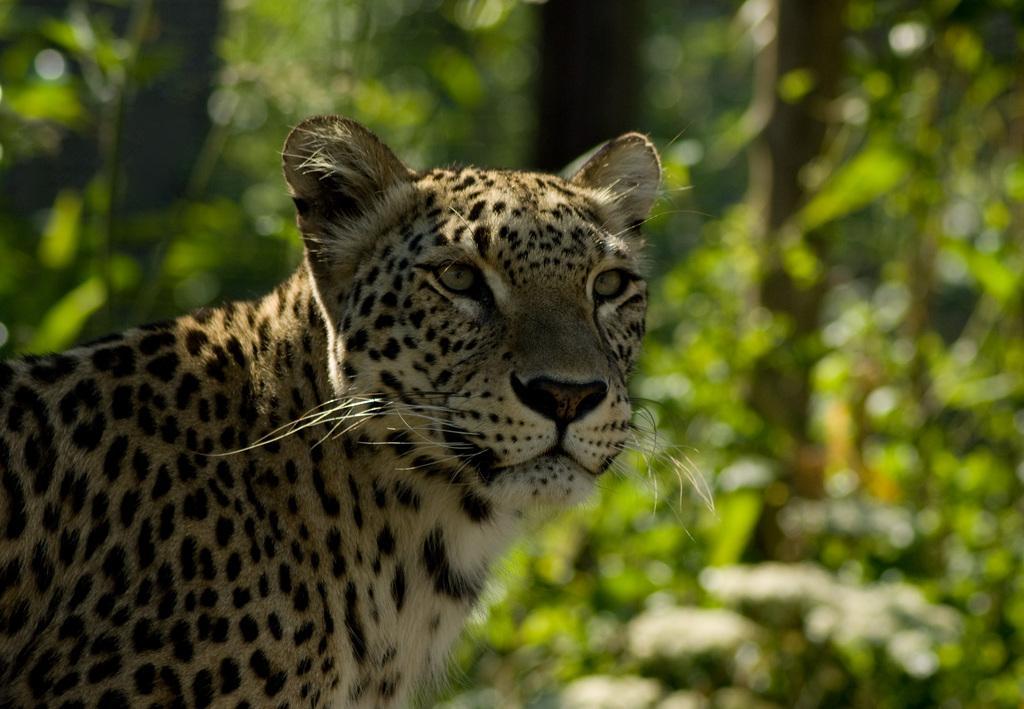Can you describe this image briefly? In this image we can see a leopard, there are trees, the background is blurry. 